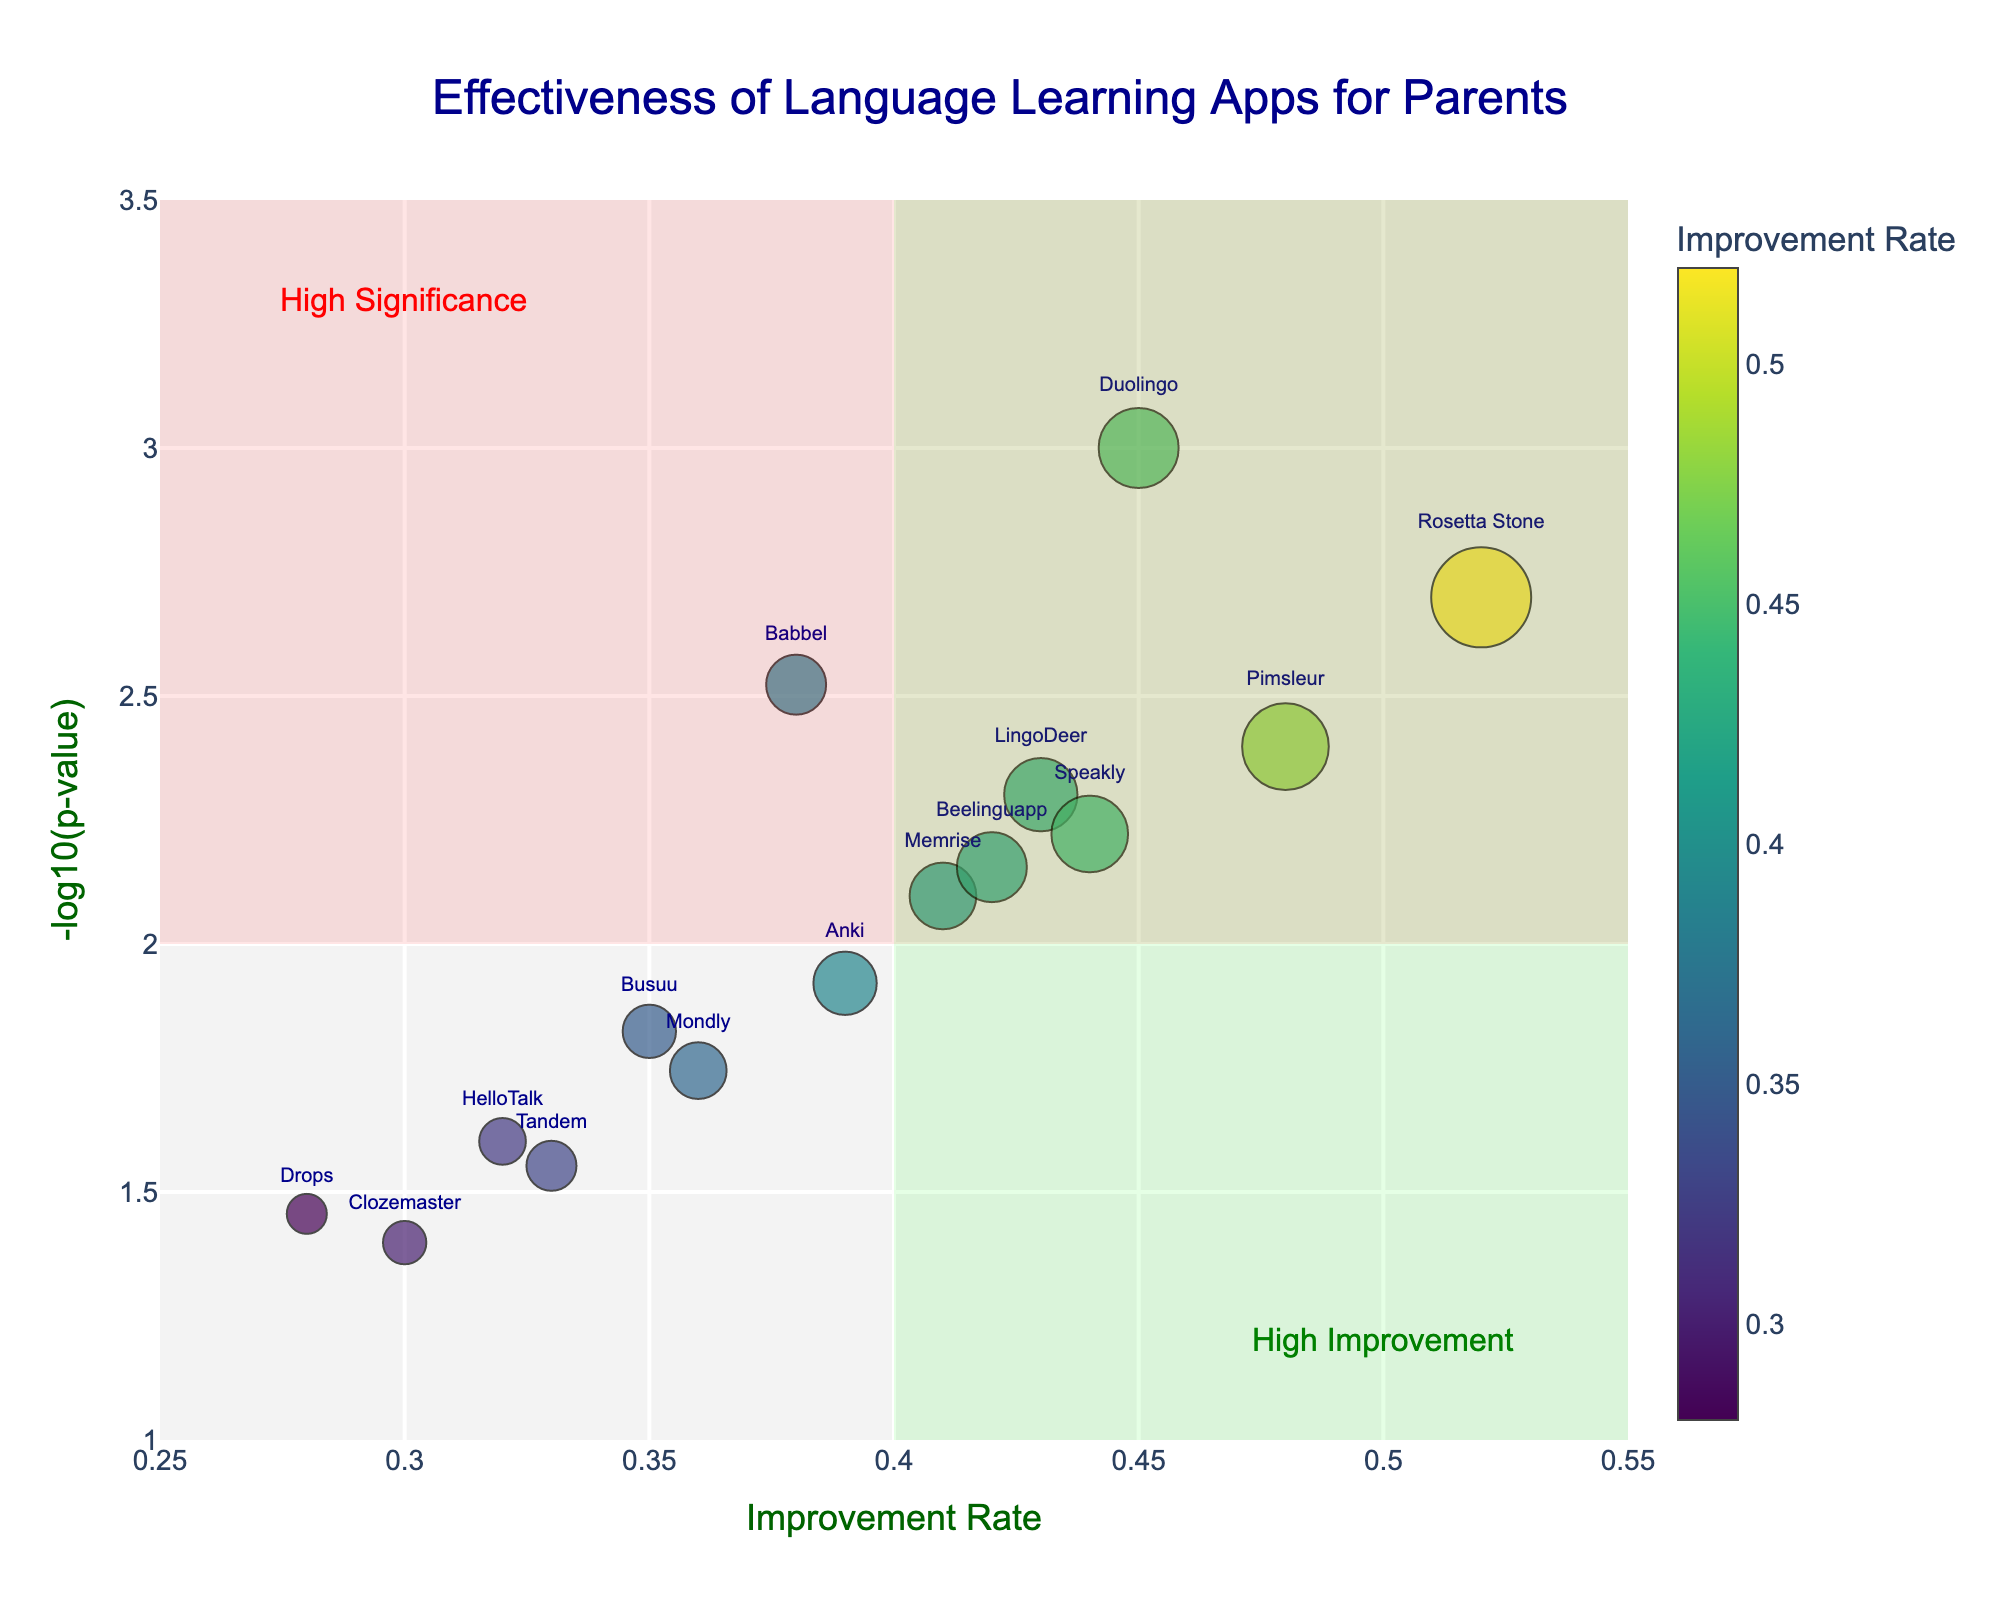Which app has the highest improvement rate? Look for the data point on the horizontal axis (Improvement Rate) that is farthest to the right. The app at this position is Rosetta Stone.
Answer: Rosetta Stone Which app has the most significant p-value? Look for the data point on the vertical axis (-log10(p-value)) that is highest. The app at this position is Duolingo.
Answer: Duolingo How many apps fall within the high significance (red shaded area)? Count the dots in the red shaded area (top part of the chart with -log10(p-value) >= 2). There are 10 such data points: Duolingo, Babbel, Rosetta Stone, Memrise, LingoDeer, Speakly, Beelinguapp, and Anki.
Answer: 8 Which apps fall under both high improvement and high significance (overlapping red and green shaded areas)? Find the intersection of the red and green shaded areas and check which apps are in both. The apps in this region are Rosetta Stone, Pimsleur, and Speakly.
Answer: Rosetta Stone, Pimsleur, Speakly Compare the improvement rate and significance of Busuu and Mondly. Which one is better? Check the improvement rate on the x-axis and the -log10(p-value) on the y-axis for Busuu (0.35, ~1.82) and Mondly (0.36, ~1.74). Since both are in grey areas, the one with higher improvement rate is better.
Answer: Mondly Which app has the lowest time invested but still shows significant improvement? Look for the smallest dot in the red shaded area, which represents the lowest time invested. Drops (with improvement rate of 0.28 and -log10(p-value) of ~1.46) meets the condition but is not in high significance. For significant improvement, Memrise is the closest.
Answer: Memrise What is the rank of HelloTalk in terms of improvement rate among all apps? Rank the improvement rates: (0.52, 0.48, 0.45, 0.44, 0.43, 0.42, 0.41, 0.39, 0.38, 0.36, 0.35, 0.33, 0.32, 0.30, 0.28). HelloTalk has an improvement rate of 0.32, placing it 12th.
Answer: 12th On average, how much time is invested by the apps with an improvement rate greater than 0.4? Add the times invested for apps with improvement rates > 0.4 (Duolingo, Rosetta Stone, Memrise, LingoDeer, Pimsleur, Beelinguapp, Speakly: 120, 150, 100, 110, 130, 105, 115 = 830). Divide by 7 to find the average: 830 / 7 = ~118.57 minutes.
Answer: ~118.57 minutes 